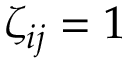Convert formula to latex. <formula><loc_0><loc_0><loc_500><loc_500>\zeta _ { i j } = 1</formula> 